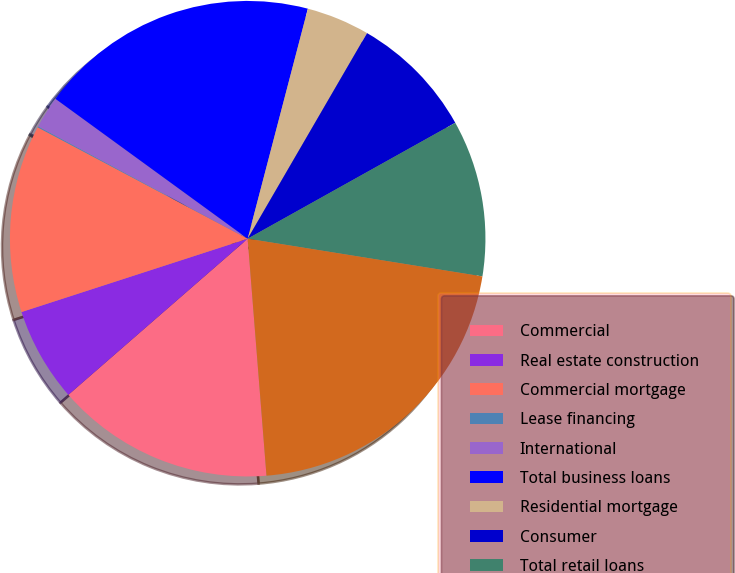<chart> <loc_0><loc_0><loc_500><loc_500><pie_chart><fcel>Commercial<fcel>Real estate construction<fcel>Commercial mortgage<fcel>Lease financing<fcel>International<fcel>Total business loans<fcel>Residential mortgage<fcel>Consumer<fcel>Total retail loans<fcel>Total loans<nl><fcel>14.86%<fcel>6.41%<fcel>12.75%<fcel>0.07%<fcel>2.18%<fcel>19.06%<fcel>4.3%<fcel>8.52%<fcel>10.64%<fcel>21.2%<nl></chart> 